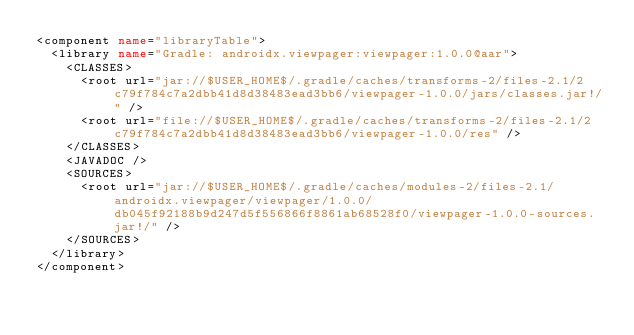Convert code to text. <code><loc_0><loc_0><loc_500><loc_500><_XML_><component name="libraryTable">
  <library name="Gradle: androidx.viewpager:viewpager:1.0.0@aar">
    <CLASSES>
      <root url="jar://$USER_HOME$/.gradle/caches/transforms-2/files-2.1/2c79f784c7a2dbb41d8d38483ead3bb6/viewpager-1.0.0/jars/classes.jar!/" />
      <root url="file://$USER_HOME$/.gradle/caches/transforms-2/files-2.1/2c79f784c7a2dbb41d8d38483ead3bb6/viewpager-1.0.0/res" />
    </CLASSES>
    <JAVADOC />
    <SOURCES>
      <root url="jar://$USER_HOME$/.gradle/caches/modules-2/files-2.1/androidx.viewpager/viewpager/1.0.0/db045f92188b9d247d5f556866f8861ab68528f0/viewpager-1.0.0-sources.jar!/" />
    </SOURCES>
  </library>
</component></code> 